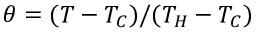Convert formula to latex. <formula><loc_0><loc_0><loc_500><loc_500>\theta = ( T - T _ { C } ) / ( T _ { H } - T _ { C } )</formula> 